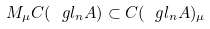Convert formula to latex. <formula><loc_0><loc_0><loc_500><loc_500>M _ { \mu } C ( \ g l _ { n } A ) \subset C ( \ g l _ { n } A ) _ { \mu }</formula> 